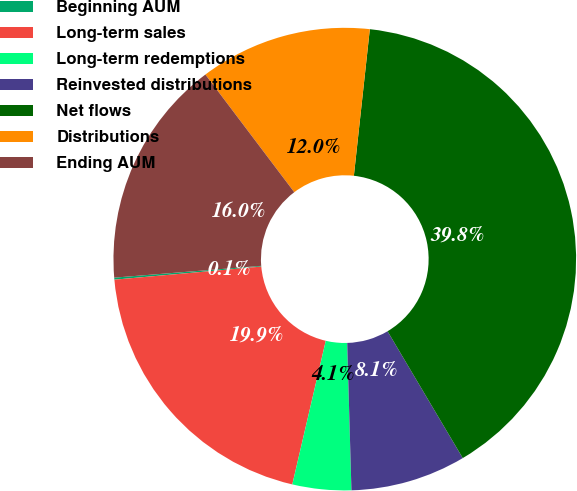<chart> <loc_0><loc_0><loc_500><loc_500><pie_chart><fcel>Beginning AUM<fcel>Long-term sales<fcel>Long-term redemptions<fcel>Reinvested distributions<fcel>Net flows<fcel>Distributions<fcel>Ending AUM<nl><fcel>0.14%<fcel>19.94%<fcel>4.1%<fcel>8.06%<fcel>39.75%<fcel>12.02%<fcel>15.98%<nl></chart> 